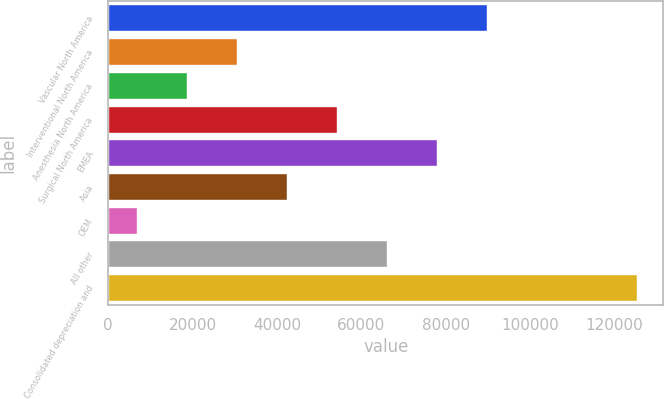Convert chart. <chart><loc_0><loc_0><loc_500><loc_500><bar_chart><fcel>Vascular North America<fcel>Interventional North America<fcel>Anesthesia North America<fcel>Surgical North America<fcel>EMEA<fcel>Asia<fcel>OEM<fcel>All other<fcel>Consolidated depreciation and<nl><fcel>89784<fcel>30534<fcel>18684<fcel>54234<fcel>77934<fcel>42384<fcel>6834<fcel>66084<fcel>125334<nl></chart> 